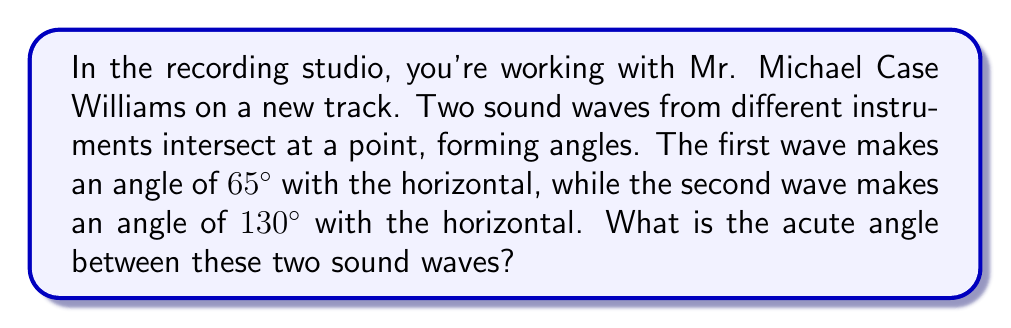Could you help me with this problem? Let's approach this step-by-step:

1) First, let's visualize the problem:

   [asy]
   import geometry;
   
   size(200);
   
   pair O=(0,0);
   pair A=dir(65);
   pair B=dir(130);
   pair H=(1,0);
   
   draw(O--A,Arrow);
   draw(O--B,Arrow);
   draw(O--H,dashed);
   
   label("65°",O,SE);
   label("130°",O,NE);
   label("Wave 1",A,NE);
   label("Wave 2",B,NW);
   
   markangle(H,O,A,radius=15);
   markangle(H,O,B,radius=25);
   [/asy]

2) The angle between the two waves is the difference between their angles with the horizontal:

   $$\text{Angle between waves} = 130° - 65° = 65°$$

3) However, this is not necessarily the acute angle. The acute angle is always the smaller of the two angles formed at the intersection.

4) To find the acute angle, we need to compare this result with its complement:

   $$\text{Complement} = 180° - 65° = 115°$$

5) The acute angle is the smaller of these two:

   $$\text{Acute angle} = \min(65°, 115°) = 65°$$

Therefore, the acute angle between the two sound waves is 65°.
Answer: 65° 